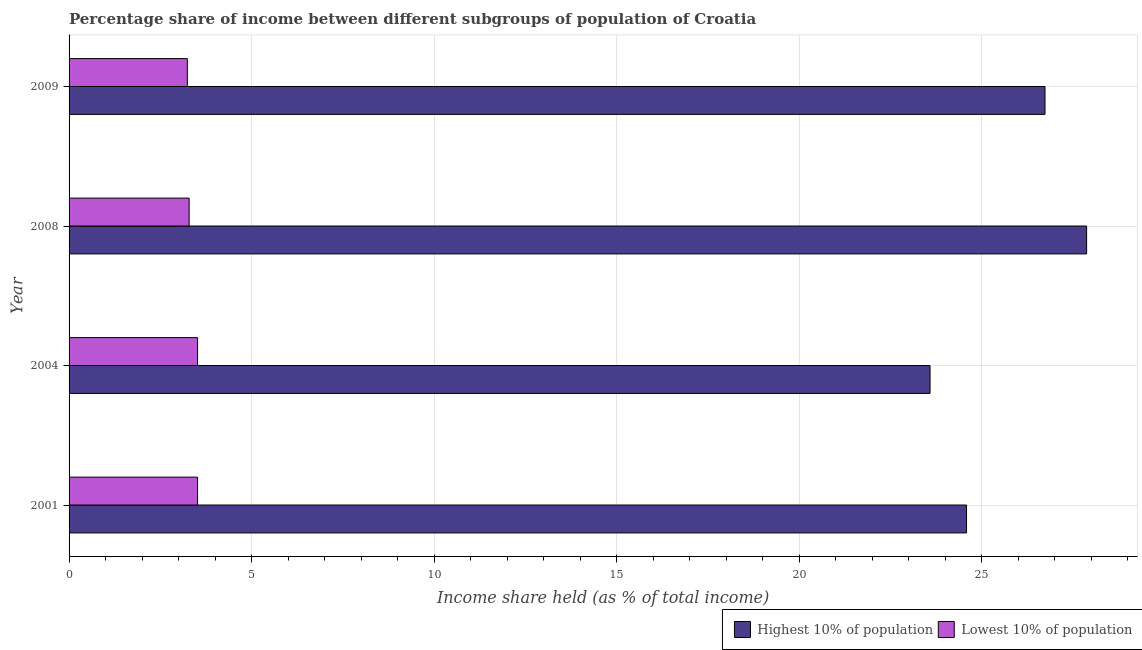How many different coloured bars are there?
Your answer should be compact. 2. Are the number of bars on each tick of the Y-axis equal?
Your answer should be compact. Yes. What is the label of the 3rd group of bars from the top?
Give a very brief answer. 2004. In how many cases, is the number of bars for a given year not equal to the number of legend labels?
Provide a short and direct response. 0. What is the income share held by highest 10% of the population in 2001?
Your response must be concise. 24.59. Across all years, what is the maximum income share held by highest 10% of the population?
Provide a short and direct response. 27.88. Across all years, what is the minimum income share held by lowest 10% of the population?
Provide a succinct answer. 3.24. In which year was the income share held by highest 10% of the population maximum?
Give a very brief answer. 2008. What is the total income share held by lowest 10% of the population in the graph?
Your answer should be compact. 13.57. What is the difference between the income share held by lowest 10% of the population in 2008 and that in 2009?
Provide a succinct answer. 0.05. What is the difference between the income share held by highest 10% of the population in 2009 and the income share held by lowest 10% of the population in 2004?
Your answer should be very brief. 23.22. What is the average income share held by highest 10% of the population per year?
Offer a very short reply. 25.7. Is the difference between the income share held by lowest 10% of the population in 2004 and 2008 greater than the difference between the income share held by highest 10% of the population in 2004 and 2008?
Provide a succinct answer. Yes. What is the difference between the highest and the second highest income share held by highest 10% of the population?
Offer a very short reply. 1.14. What is the difference between the highest and the lowest income share held by lowest 10% of the population?
Make the answer very short. 0.28. In how many years, is the income share held by lowest 10% of the population greater than the average income share held by lowest 10% of the population taken over all years?
Offer a terse response. 2. Is the sum of the income share held by lowest 10% of the population in 2001 and 2008 greater than the maximum income share held by highest 10% of the population across all years?
Ensure brevity in your answer.  No. What does the 2nd bar from the top in 2008 represents?
Offer a very short reply. Highest 10% of population. What does the 1st bar from the bottom in 2009 represents?
Your answer should be very brief. Highest 10% of population. How many bars are there?
Offer a terse response. 8. Are all the bars in the graph horizontal?
Keep it short and to the point. Yes. How many years are there in the graph?
Ensure brevity in your answer.  4. What is the difference between two consecutive major ticks on the X-axis?
Offer a very short reply. 5. What is the title of the graph?
Ensure brevity in your answer.  Percentage share of income between different subgroups of population of Croatia. Does "Working capital" appear as one of the legend labels in the graph?
Make the answer very short. No. What is the label or title of the X-axis?
Provide a short and direct response. Income share held (as % of total income). What is the label or title of the Y-axis?
Your response must be concise. Year. What is the Income share held (as % of total income) in Highest 10% of population in 2001?
Provide a succinct answer. 24.59. What is the Income share held (as % of total income) in Lowest 10% of population in 2001?
Ensure brevity in your answer.  3.52. What is the Income share held (as % of total income) in Highest 10% of population in 2004?
Make the answer very short. 23.59. What is the Income share held (as % of total income) of Lowest 10% of population in 2004?
Provide a short and direct response. 3.52. What is the Income share held (as % of total income) of Highest 10% of population in 2008?
Provide a short and direct response. 27.88. What is the Income share held (as % of total income) of Lowest 10% of population in 2008?
Make the answer very short. 3.29. What is the Income share held (as % of total income) in Highest 10% of population in 2009?
Your answer should be very brief. 26.74. What is the Income share held (as % of total income) in Lowest 10% of population in 2009?
Your answer should be compact. 3.24. Across all years, what is the maximum Income share held (as % of total income) of Highest 10% of population?
Make the answer very short. 27.88. Across all years, what is the maximum Income share held (as % of total income) in Lowest 10% of population?
Offer a terse response. 3.52. Across all years, what is the minimum Income share held (as % of total income) in Highest 10% of population?
Ensure brevity in your answer.  23.59. Across all years, what is the minimum Income share held (as % of total income) of Lowest 10% of population?
Offer a very short reply. 3.24. What is the total Income share held (as % of total income) of Highest 10% of population in the graph?
Your answer should be very brief. 102.8. What is the total Income share held (as % of total income) in Lowest 10% of population in the graph?
Make the answer very short. 13.57. What is the difference between the Income share held (as % of total income) in Lowest 10% of population in 2001 and that in 2004?
Provide a short and direct response. 0. What is the difference between the Income share held (as % of total income) of Highest 10% of population in 2001 and that in 2008?
Your answer should be compact. -3.29. What is the difference between the Income share held (as % of total income) of Lowest 10% of population in 2001 and that in 2008?
Your answer should be compact. 0.23. What is the difference between the Income share held (as % of total income) of Highest 10% of population in 2001 and that in 2009?
Keep it short and to the point. -2.15. What is the difference between the Income share held (as % of total income) of Lowest 10% of population in 2001 and that in 2009?
Your answer should be compact. 0.28. What is the difference between the Income share held (as % of total income) in Highest 10% of population in 2004 and that in 2008?
Your answer should be very brief. -4.29. What is the difference between the Income share held (as % of total income) in Lowest 10% of population in 2004 and that in 2008?
Provide a succinct answer. 0.23. What is the difference between the Income share held (as % of total income) of Highest 10% of population in 2004 and that in 2009?
Provide a succinct answer. -3.15. What is the difference between the Income share held (as % of total income) in Lowest 10% of population in 2004 and that in 2009?
Your response must be concise. 0.28. What is the difference between the Income share held (as % of total income) in Highest 10% of population in 2008 and that in 2009?
Offer a very short reply. 1.14. What is the difference between the Income share held (as % of total income) in Lowest 10% of population in 2008 and that in 2009?
Your answer should be compact. 0.05. What is the difference between the Income share held (as % of total income) of Highest 10% of population in 2001 and the Income share held (as % of total income) of Lowest 10% of population in 2004?
Ensure brevity in your answer.  21.07. What is the difference between the Income share held (as % of total income) in Highest 10% of population in 2001 and the Income share held (as % of total income) in Lowest 10% of population in 2008?
Offer a very short reply. 21.3. What is the difference between the Income share held (as % of total income) of Highest 10% of population in 2001 and the Income share held (as % of total income) of Lowest 10% of population in 2009?
Your response must be concise. 21.35. What is the difference between the Income share held (as % of total income) of Highest 10% of population in 2004 and the Income share held (as % of total income) of Lowest 10% of population in 2008?
Your answer should be compact. 20.3. What is the difference between the Income share held (as % of total income) in Highest 10% of population in 2004 and the Income share held (as % of total income) in Lowest 10% of population in 2009?
Make the answer very short. 20.35. What is the difference between the Income share held (as % of total income) of Highest 10% of population in 2008 and the Income share held (as % of total income) of Lowest 10% of population in 2009?
Provide a short and direct response. 24.64. What is the average Income share held (as % of total income) in Highest 10% of population per year?
Offer a very short reply. 25.7. What is the average Income share held (as % of total income) in Lowest 10% of population per year?
Provide a short and direct response. 3.39. In the year 2001, what is the difference between the Income share held (as % of total income) in Highest 10% of population and Income share held (as % of total income) in Lowest 10% of population?
Offer a very short reply. 21.07. In the year 2004, what is the difference between the Income share held (as % of total income) in Highest 10% of population and Income share held (as % of total income) in Lowest 10% of population?
Offer a very short reply. 20.07. In the year 2008, what is the difference between the Income share held (as % of total income) in Highest 10% of population and Income share held (as % of total income) in Lowest 10% of population?
Provide a succinct answer. 24.59. What is the ratio of the Income share held (as % of total income) in Highest 10% of population in 2001 to that in 2004?
Give a very brief answer. 1.04. What is the ratio of the Income share held (as % of total income) in Highest 10% of population in 2001 to that in 2008?
Your response must be concise. 0.88. What is the ratio of the Income share held (as % of total income) in Lowest 10% of population in 2001 to that in 2008?
Make the answer very short. 1.07. What is the ratio of the Income share held (as % of total income) in Highest 10% of population in 2001 to that in 2009?
Offer a very short reply. 0.92. What is the ratio of the Income share held (as % of total income) of Lowest 10% of population in 2001 to that in 2009?
Your response must be concise. 1.09. What is the ratio of the Income share held (as % of total income) in Highest 10% of population in 2004 to that in 2008?
Your answer should be compact. 0.85. What is the ratio of the Income share held (as % of total income) of Lowest 10% of population in 2004 to that in 2008?
Your response must be concise. 1.07. What is the ratio of the Income share held (as % of total income) in Highest 10% of population in 2004 to that in 2009?
Your answer should be very brief. 0.88. What is the ratio of the Income share held (as % of total income) in Lowest 10% of population in 2004 to that in 2009?
Offer a very short reply. 1.09. What is the ratio of the Income share held (as % of total income) of Highest 10% of population in 2008 to that in 2009?
Give a very brief answer. 1.04. What is the ratio of the Income share held (as % of total income) of Lowest 10% of population in 2008 to that in 2009?
Provide a short and direct response. 1.02. What is the difference between the highest and the second highest Income share held (as % of total income) in Highest 10% of population?
Offer a terse response. 1.14. What is the difference between the highest and the second highest Income share held (as % of total income) of Lowest 10% of population?
Offer a very short reply. 0. What is the difference between the highest and the lowest Income share held (as % of total income) of Highest 10% of population?
Provide a succinct answer. 4.29. What is the difference between the highest and the lowest Income share held (as % of total income) in Lowest 10% of population?
Keep it short and to the point. 0.28. 